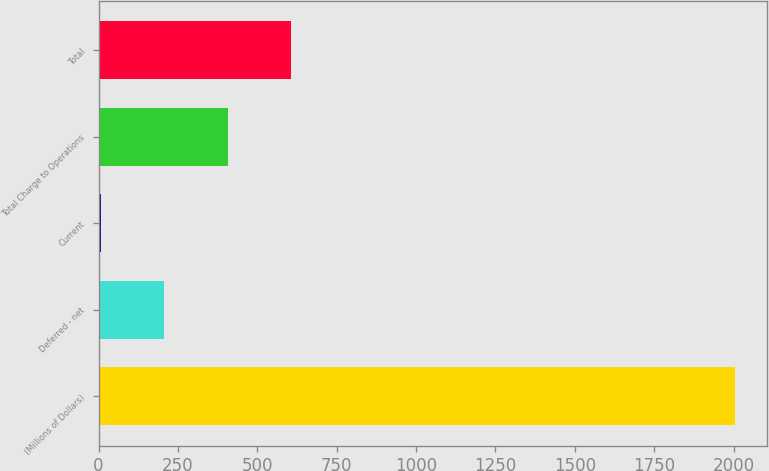Convert chart to OTSL. <chart><loc_0><loc_0><loc_500><loc_500><bar_chart><fcel>(Millions of Dollars)<fcel>Deferred - net<fcel>Current<fcel>Total Charge to Operations<fcel>Total<nl><fcel>2004<fcel>206.7<fcel>7<fcel>406.4<fcel>606.1<nl></chart> 